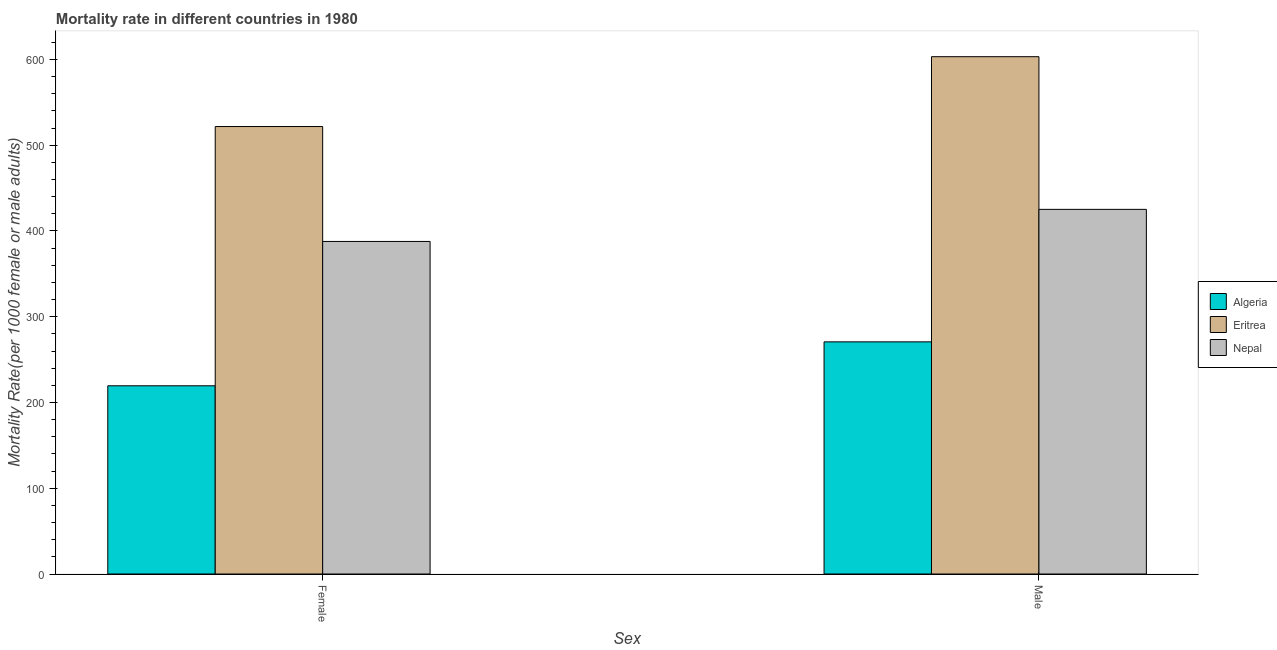Are the number of bars on each tick of the X-axis equal?
Give a very brief answer. Yes. How many bars are there on the 1st tick from the right?
Your response must be concise. 3. What is the label of the 2nd group of bars from the left?
Make the answer very short. Male. What is the female mortality rate in Nepal?
Ensure brevity in your answer.  387.74. Across all countries, what is the maximum female mortality rate?
Provide a succinct answer. 521.71. Across all countries, what is the minimum female mortality rate?
Ensure brevity in your answer.  219.44. In which country was the male mortality rate maximum?
Offer a terse response. Eritrea. In which country was the male mortality rate minimum?
Ensure brevity in your answer.  Algeria. What is the total male mortality rate in the graph?
Ensure brevity in your answer.  1298.96. What is the difference between the male mortality rate in Eritrea and that in Algeria?
Give a very brief answer. 332.5. What is the difference between the male mortality rate in Eritrea and the female mortality rate in Nepal?
Give a very brief answer. 215.41. What is the average female mortality rate per country?
Offer a very short reply. 376.3. What is the difference between the male mortality rate and female mortality rate in Eritrea?
Make the answer very short. 81.44. In how many countries, is the female mortality rate greater than 340 ?
Give a very brief answer. 2. What is the ratio of the male mortality rate in Nepal to that in Algeria?
Offer a terse response. 1.57. Is the male mortality rate in Algeria less than that in Nepal?
Give a very brief answer. Yes. In how many countries, is the female mortality rate greater than the average female mortality rate taken over all countries?
Your answer should be very brief. 2. What does the 1st bar from the left in Male represents?
Make the answer very short. Algeria. What does the 1st bar from the right in Female represents?
Ensure brevity in your answer.  Nepal. How many bars are there?
Ensure brevity in your answer.  6. What is the difference between two consecutive major ticks on the Y-axis?
Ensure brevity in your answer.  100. How many legend labels are there?
Offer a terse response. 3. What is the title of the graph?
Give a very brief answer. Mortality rate in different countries in 1980. What is the label or title of the X-axis?
Provide a succinct answer. Sex. What is the label or title of the Y-axis?
Make the answer very short. Mortality Rate(per 1000 female or male adults). What is the Mortality Rate(per 1000 female or male adults) in Algeria in Female?
Give a very brief answer. 219.44. What is the Mortality Rate(per 1000 female or male adults) of Eritrea in Female?
Provide a short and direct response. 521.71. What is the Mortality Rate(per 1000 female or male adults) in Nepal in Female?
Your response must be concise. 387.74. What is the Mortality Rate(per 1000 female or male adults) in Algeria in Male?
Offer a very short reply. 270.66. What is the Mortality Rate(per 1000 female or male adults) in Eritrea in Male?
Give a very brief answer. 603.16. What is the Mortality Rate(per 1000 female or male adults) of Nepal in Male?
Offer a very short reply. 425.14. Across all Sex, what is the maximum Mortality Rate(per 1000 female or male adults) of Algeria?
Provide a short and direct response. 270.66. Across all Sex, what is the maximum Mortality Rate(per 1000 female or male adults) of Eritrea?
Your answer should be compact. 603.16. Across all Sex, what is the maximum Mortality Rate(per 1000 female or male adults) in Nepal?
Your answer should be very brief. 425.14. Across all Sex, what is the minimum Mortality Rate(per 1000 female or male adults) of Algeria?
Your answer should be compact. 219.44. Across all Sex, what is the minimum Mortality Rate(per 1000 female or male adults) of Eritrea?
Offer a terse response. 521.71. Across all Sex, what is the minimum Mortality Rate(per 1000 female or male adults) of Nepal?
Provide a succinct answer. 387.74. What is the total Mortality Rate(per 1000 female or male adults) in Algeria in the graph?
Provide a succinct answer. 490.1. What is the total Mortality Rate(per 1000 female or male adults) in Eritrea in the graph?
Give a very brief answer. 1124.87. What is the total Mortality Rate(per 1000 female or male adults) of Nepal in the graph?
Provide a short and direct response. 812.88. What is the difference between the Mortality Rate(per 1000 female or male adults) in Algeria in Female and that in Male?
Your answer should be compact. -51.22. What is the difference between the Mortality Rate(per 1000 female or male adults) of Eritrea in Female and that in Male?
Provide a succinct answer. -81.44. What is the difference between the Mortality Rate(per 1000 female or male adults) of Nepal in Female and that in Male?
Keep it short and to the point. -37.4. What is the difference between the Mortality Rate(per 1000 female or male adults) in Algeria in Female and the Mortality Rate(per 1000 female or male adults) in Eritrea in Male?
Your answer should be very brief. -383.72. What is the difference between the Mortality Rate(per 1000 female or male adults) in Algeria in Female and the Mortality Rate(per 1000 female or male adults) in Nepal in Male?
Provide a succinct answer. -205.7. What is the difference between the Mortality Rate(per 1000 female or male adults) in Eritrea in Female and the Mortality Rate(per 1000 female or male adults) in Nepal in Male?
Your response must be concise. 96.57. What is the average Mortality Rate(per 1000 female or male adults) in Algeria per Sex?
Keep it short and to the point. 245.05. What is the average Mortality Rate(per 1000 female or male adults) of Eritrea per Sex?
Offer a terse response. 562.43. What is the average Mortality Rate(per 1000 female or male adults) of Nepal per Sex?
Your response must be concise. 406.44. What is the difference between the Mortality Rate(per 1000 female or male adults) in Algeria and Mortality Rate(per 1000 female or male adults) in Eritrea in Female?
Offer a very short reply. -302.27. What is the difference between the Mortality Rate(per 1000 female or male adults) of Algeria and Mortality Rate(per 1000 female or male adults) of Nepal in Female?
Keep it short and to the point. -168.3. What is the difference between the Mortality Rate(per 1000 female or male adults) in Eritrea and Mortality Rate(per 1000 female or male adults) in Nepal in Female?
Your response must be concise. 133.97. What is the difference between the Mortality Rate(per 1000 female or male adults) of Algeria and Mortality Rate(per 1000 female or male adults) of Eritrea in Male?
Ensure brevity in your answer.  -332.5. What is the difference between the Mortality Rate(per 1000 female or male adults) in Algeria and Mortality Rate(per 1000 female or male adults) in Nepal in Male?
Your response must be concise. -154.48. What is the difference between the Mortality Rate(per 1000 female or male adults) in Eritrea and Mortality Rate(per 1000 female or male adults) in Nepal in Male?
Ensure brevity in your answer.  178.01. What is the ratio of the Mortality Rate(per 1000 female or male adults) in Algeria in Female to that in Male?
Provide a short and direct response. 0.81. What is the ratio of the Mortality Rate(per 1000 female or male adults) in Eritrea in Female to that in Male?
Your answer should be very brief. 0.86. What is the ratio of the Mortality Rate(per 1000 female or male adults) of Nepal in Female to that in Male?
Ensure brevity in your answer.  0.91. What is the difference between the highest and the second highest Mortality Rate(per 1000 female or male adults) of Algeria?
Your answer should be very brief. 51.22. What is the difference between the highest and the second highest Mortality Rate(per 1000 female or male adults) in Eritrea?
Ensure brevity in your answer.  81.44. What is the difference between the highest and the second highest Mortality Rate(per 1000 female or male adults) of Nepal?
Your answer should be compact. 37.4. What is the difference between the highest and the lowest Mortality Rate(per 1000 female or male adults) of Algeria?
Offer a very short reply. 51.22. What is the difference between the highest and the lowest Mortality Rate(per 1000 female or male adults) in Eritrea?
Offer a very short reply. 81.44. What is the difference between the highest and the lowest Mortality Rate(per 1000 female or male adults) of Nepal?
Offer a terse response. 37.4. 